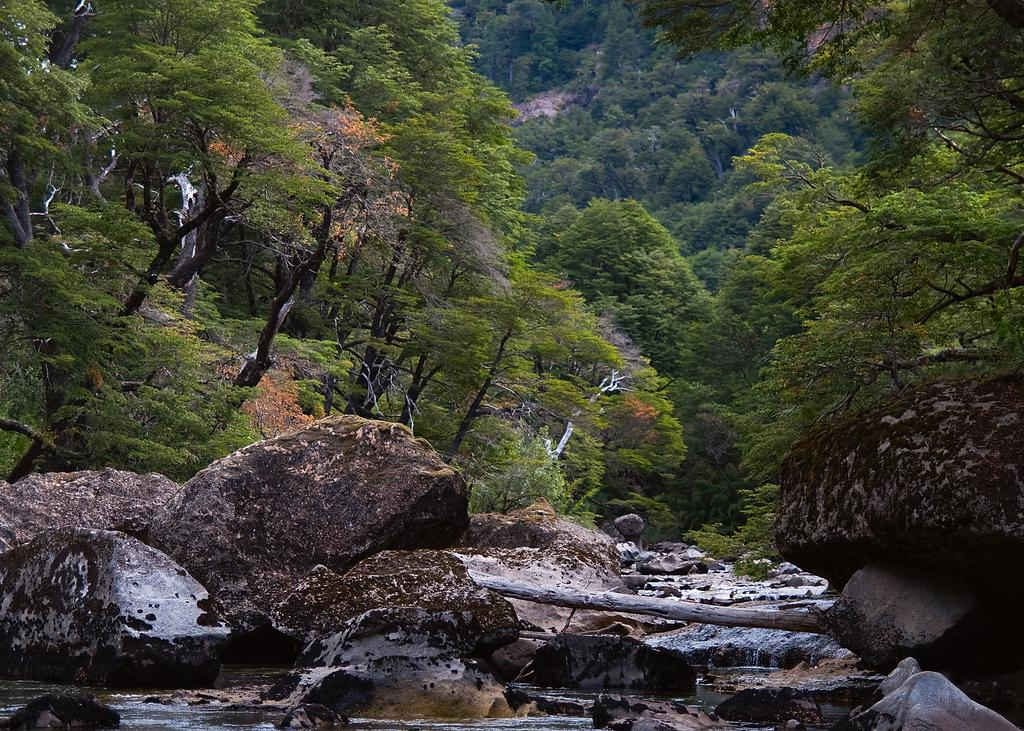What type of vegetation can be seen in the image? There are trees in the image. What other objects are present in the image besides trees? There are stones in the image. What type of engine is powering the trees in the image? There is no engine present in the image, as trees are living organisms and do not require engines for growth or movement. 